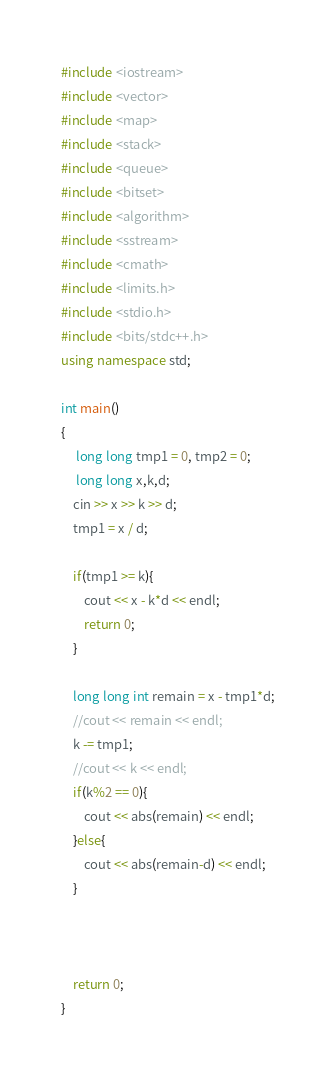Convert code to text. <code><loc_0><loc_0><loc_500><loc_500><_C++_>#include <iostream>
#include <vector>
#include <map>
#include <stack>
#include <queue>
#include <bitset>
#include <algorithm>
#include <sstream>
#include <cmath>
#include <limits.h>
#include <stdio.h>
#include <bits/stdc++.h>
using namespace std;

int main()
{
     long long tmp1 = 0, tmp2 = 0;
     long long x,k,d;
    cin >> x >> k >> d;
    tmp1 = x / d;
    
    if(tmp1 >= k){
        cout << x - k*d << endl;
        return 0;
    }
    
    long long int remain = x - tmp1*d;
    //cout << remain << endl;
    k -= tmp1;
    //cout << k << endl;
    if(k%2 == 0){
        cout << abs(remain) << endl;
    }else{
        cout << abs(remain-d) << endl;
    }
       
 
    
    return 0;
}</code> 